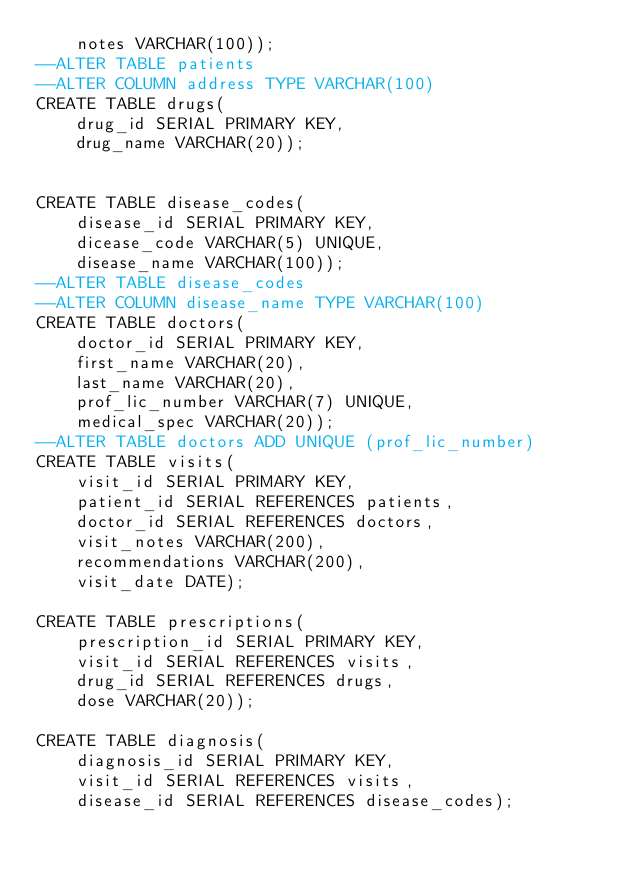<code> <loc_0><loc_0><loc_500><loc_500><_SQL_>	notes VARCHAR(100));
--ALTER TABLE patients
--ALTER COLUMN address TYPE VARCHAR(100)
CREATE TABLE drugs(
	drug_id SERIAL PRIMARY KEY,
	drug_name VARCHAR(20));


CREATE TABLE disease_codes(
	disease_id SERIAL PRIMARY KEY,
	dicease_code VARCHAR(5) UNIQUE,
	disease_name VARCHAR(100));
--ALTER TABLE disease_codes
--ALTER COLUMN disease_name TYPE VARCHAR(100)
CREATE TABLE doctors(
	doctor_id SERIAL PRIMARY KEY,
	first_name VARCHAR(20),
	last_name VARCHAR(20),
	prof_lic_number VARCHAR(7) UNIQUE,
	medical_spec VARCHAR(20));
--ALTER TABLE doctors ADD UNIQUE (prof_lic_number)
CREATE TABLE visits(
	visit_id SERIAL PRIMARY KEY,
	patient_id SERIAL REFERENCES patients,
	doctor_id SERIAL REFERENCES doctors,
	visit_notes VARCHAR(200),
	recommendations VARCHAR(200),
	visit_date DATE);

CREATE TABLE prescriptions(
	prescription_id SERIAL PRIMARY KEY,
	visit_id SERIAL REFERENCES visits,
	drug_id SERIAL REFERENCES drugs,
	dose VARCHAR(20));

CREATE TABLE diagnosis(
	diagnosis_id SERIAL PRIMARY KEY,
	visit_id SERIAL REFERENCES visits,
	disease_id SERIAL REFERENCES disease_codes);

</code> 